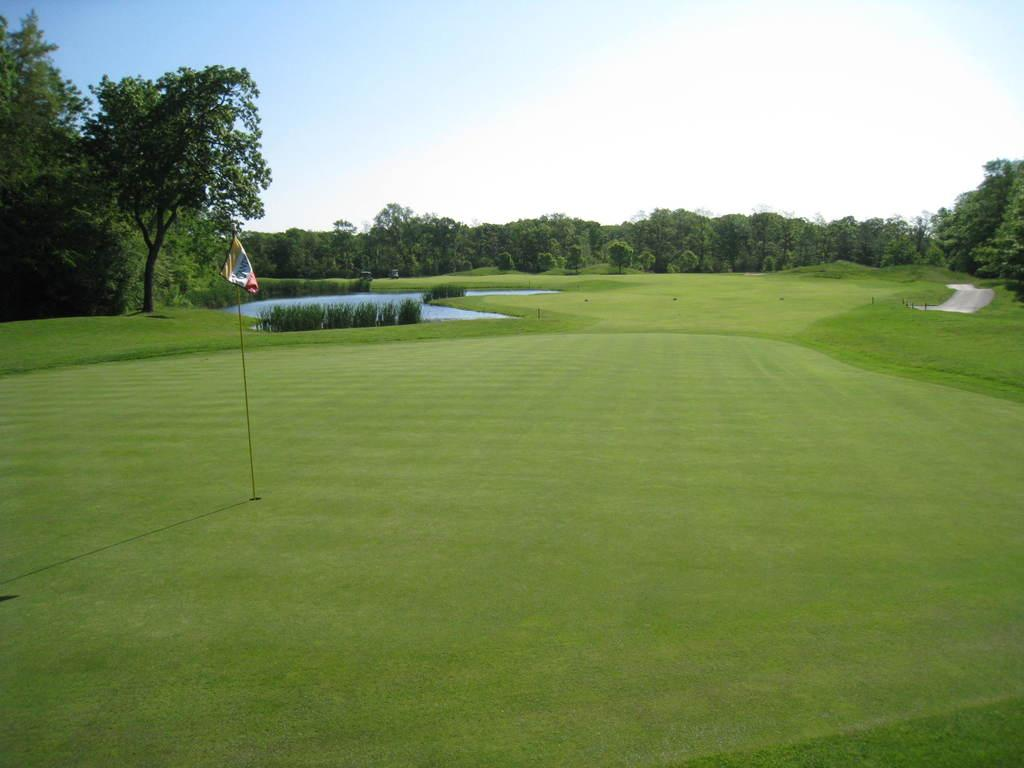What type of vegetation can be seen in the image? There are plants, trees, and grass visible in the image. What is the source of water in the image? The water is visible in the image, but the source is not specified. What is the object with a distinct pattern in the image? There is a flag in the image with a distinct pattern. What is visible in the background of the image? The sky is visible in the background of the image. What flavor of ice cream is being served at the event in the image? There is no event or ice cream present in the image. Can you spot an ant crawling on the leaves of the plants in the image? There is no ant visible in the image. 